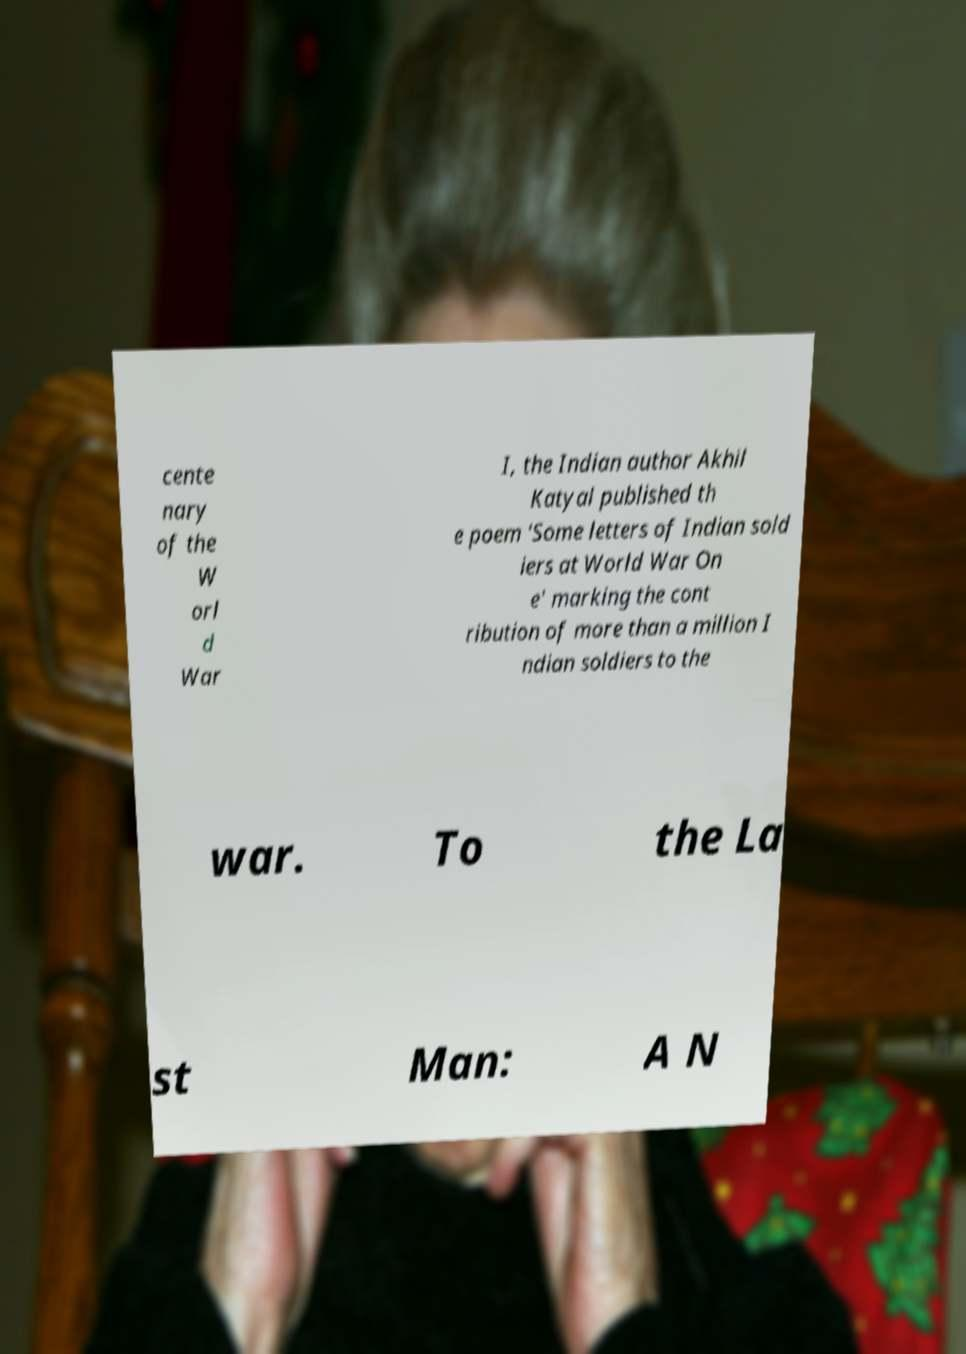Can you accurately transcribe the text from the provided image for me? cente nary of the W orl d War I, the Indian author Akhil Katyal published th e poem 'Some letters of Indian sold iers at World War On e' marking the cont ribution of more than a million I ndian soldiers to the war. To the La st Man: A N 